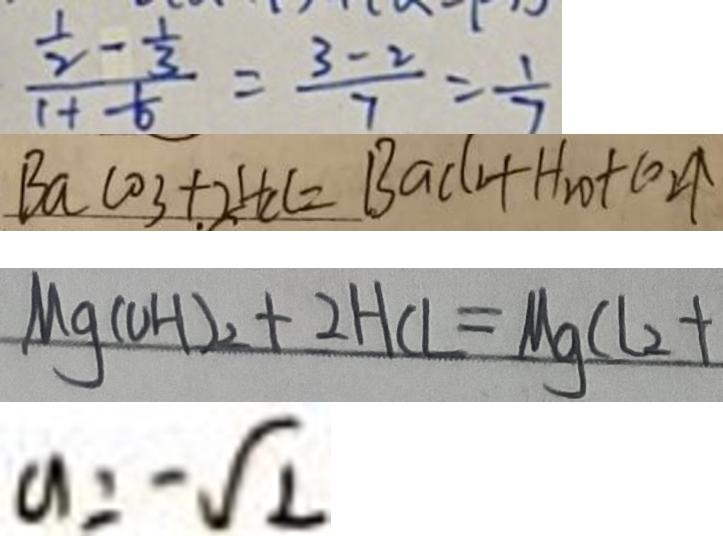Convert formula to latex. <formula><loc_0><loc_0><loc_500><loc_500>\frac { \frac { 1 } { 2 } - \frac { 1 } { 3 } } { 1 + \frac { 1 } { 6 } } = \frac { 3 - 2 } { 7 } = \frac { 1 } { 7 } 
 B a \cos + 2 H C l = B a c ( 1 + H _ { 2 } O + C O _ { 2 } \uparrow 
 M g ( O H ) _ { 2 } + 2 H C l = M g C l _ { 2 } + 
 a = - \sqrt { 2 }</formula> 